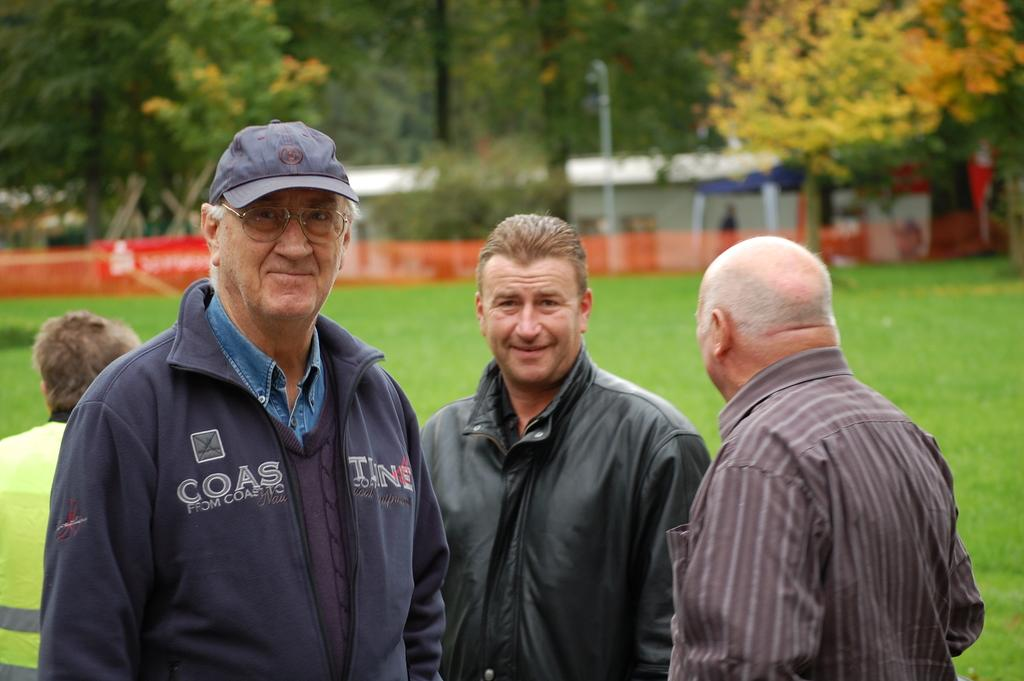How many old men are in the image? There are three old men in the image. What are the old men wearing? The old men are wearing jackets or sweatshirts. What are the old men doing in the image? The old men are standing. Can you describe the person on the left side of the image? There is another person visible on the left side of the image. What can be seen in the background of the image? There is a grassland and trees in the background of the image. What type of locket is the old man holding in the image? There is no locket present in the image; the old men are wearing jackets or sweatshirts and standing. Which old man has a knee injury in the image? There is no mention of any knee injuries or medical conditions in the image. 